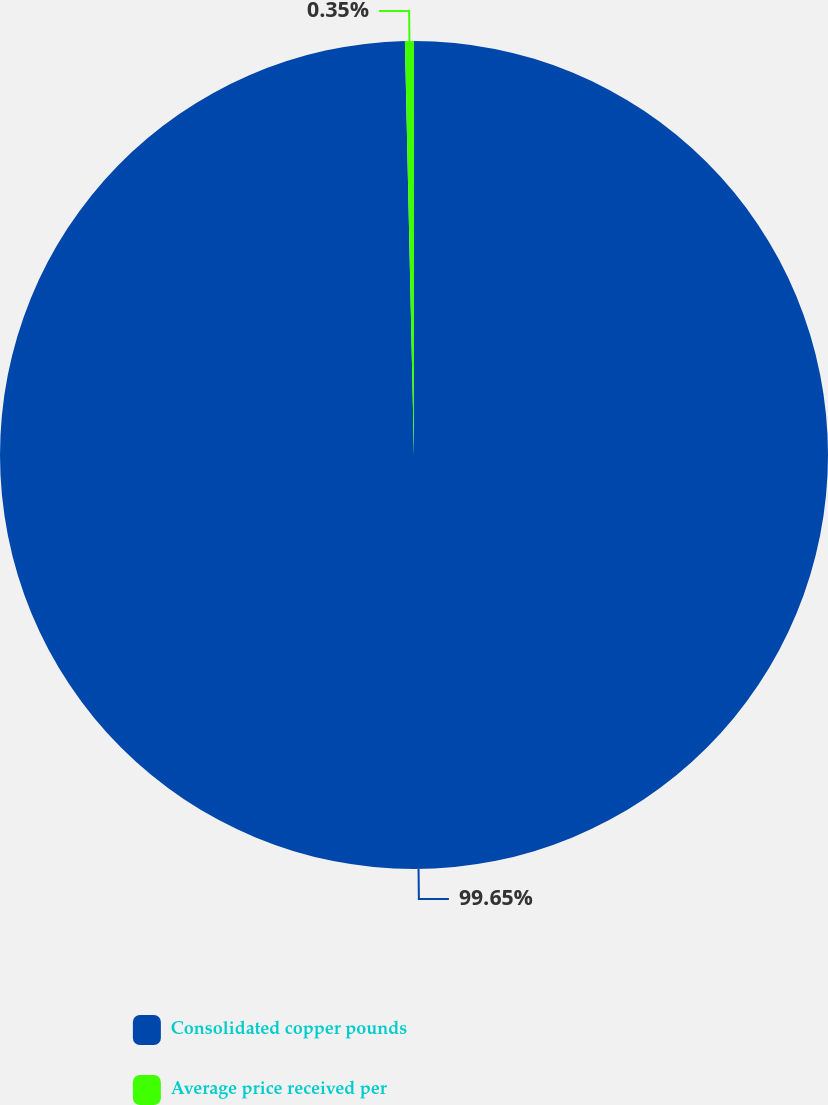Convert chart to OTSL. <chart><loc_0><loc_0><loc_500><loc_500><pie_chart><fcel>Consolidated copper pounds<fcel>Average price received per<nl><fcel>99.65%<fcel>0.35%<nl></chart> 